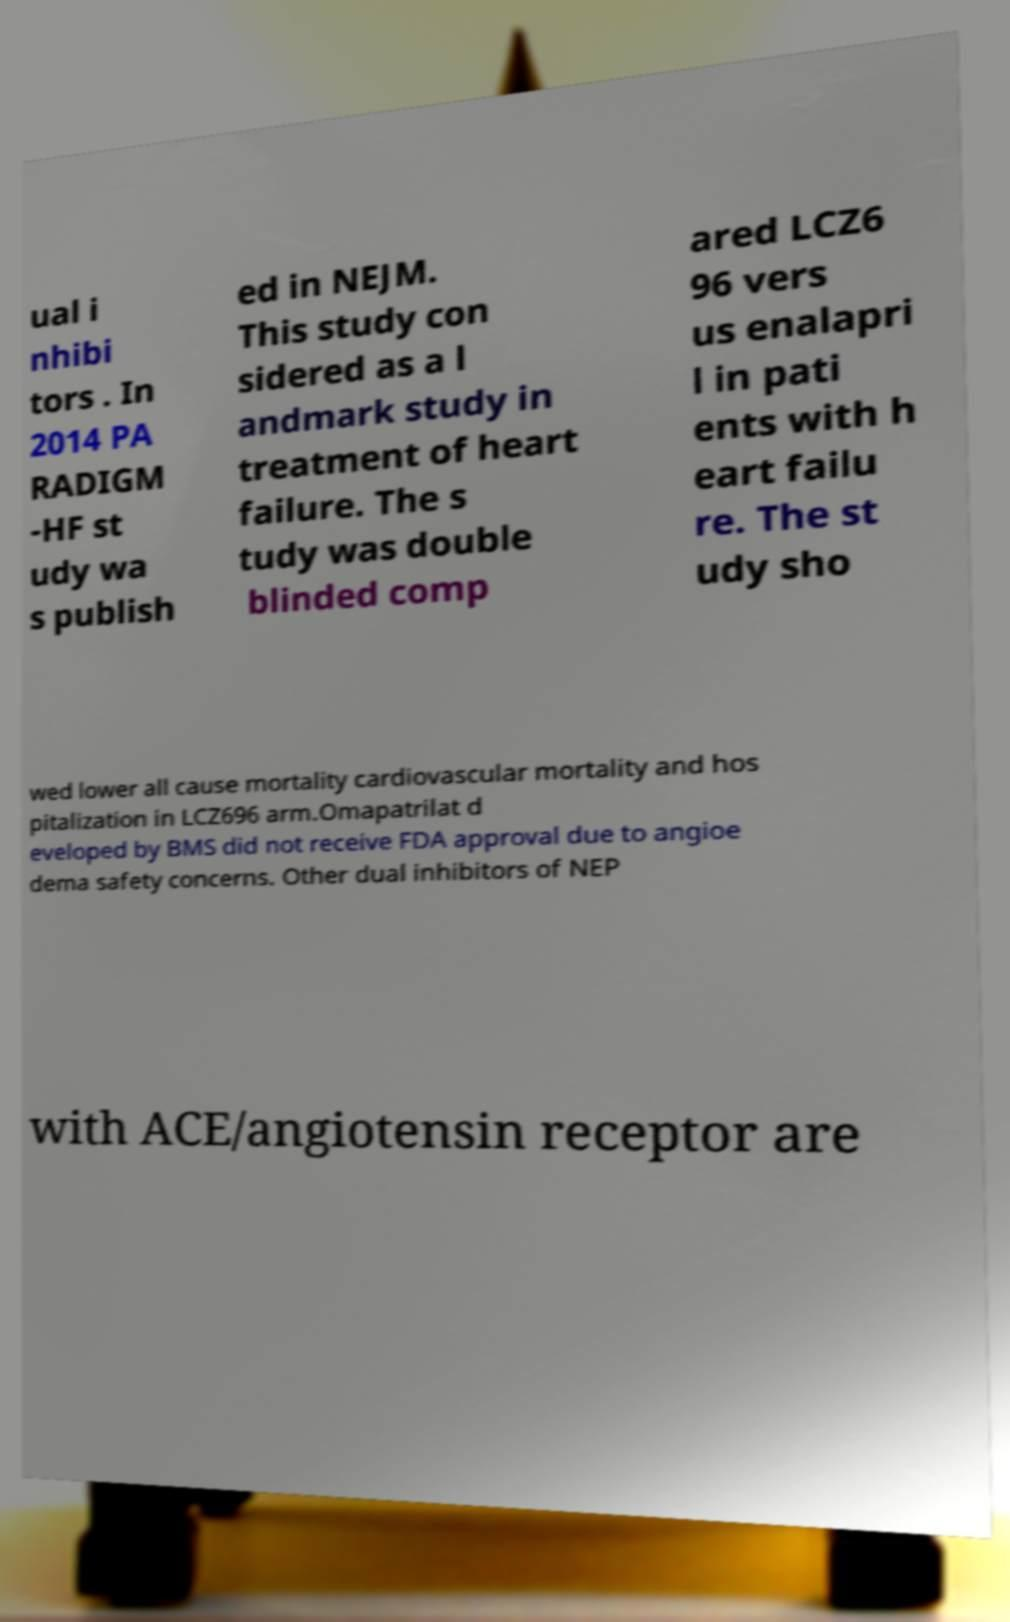I need the written content from this picture converted into text. Can you do that? ual i nhibi tors . In 2014 PA RADIGM -HF st udy wa s publish ed in NEJM. This study con sidered as a l andmark study in treatment of heart failure. The s tudy was double blinded comp ared LCZ6 96 vers us enalapri l in pati ents with h eart failu re. The st udy sho wed lower all cause mortality cardiovascular mortality and hos pitalization in LCZ696 arm.Omapatrilat d eveloped by BMS did not receive FDA approval due to angioe dema safety concerns. Other dual inhibitors of NEP with ACE/angiotensin receptor are 